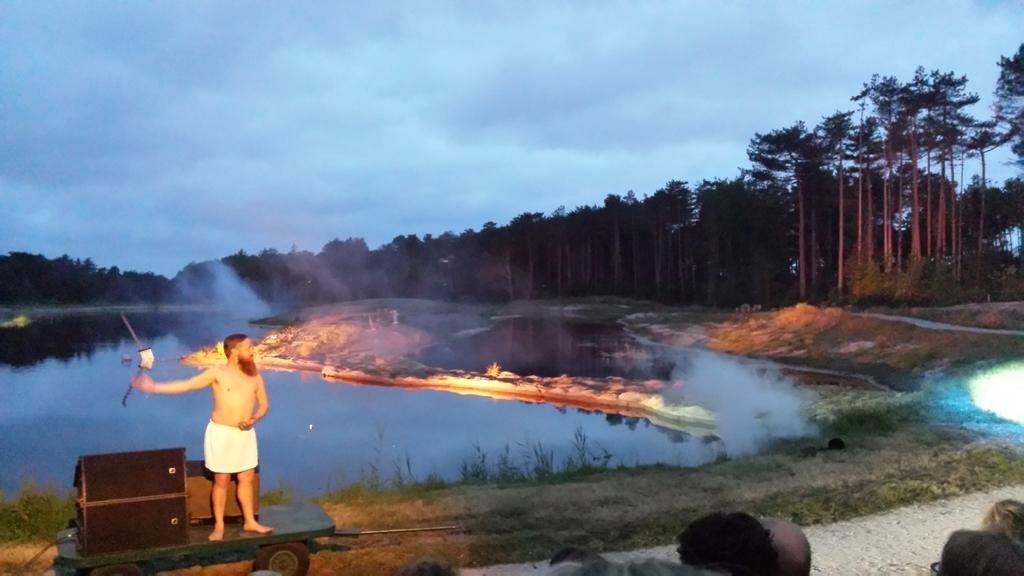What is the main subject in the image? There is a man standing in the image. What type of natural environment is visible in the image? There is grass, water, and trees visible in the image. What is the condition of the sky in the image? The sky is cloudy in the image. Are there any other people present in the image? Yes, there are other people in the image. What type of rose is being held by the man's aunt in the image? There is no mention of an aunt or a rose in the image, so this question cannot be answered. 